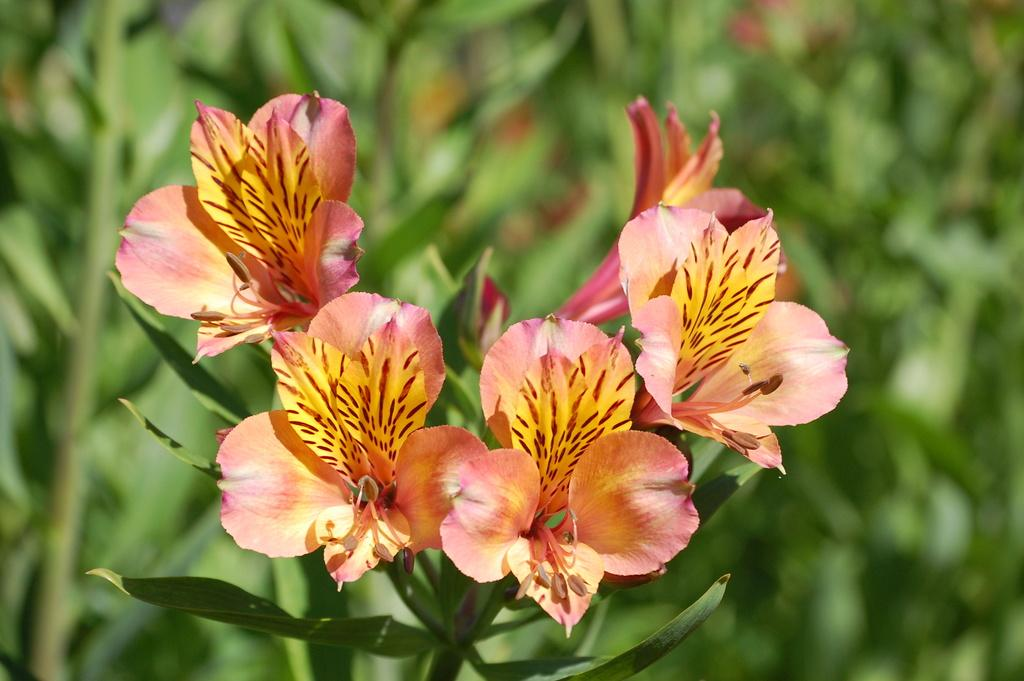What type of plants are in the image? There are flowers in the image. What part of the flowers can be seen in the image? The flowers have stems in the image. Can you describe the background of the image? The background of the image is blurred. What type of sack can be seen in the image? There is no sack present in the image. How many balls are visible in the image? There are no balls visible in the image. 